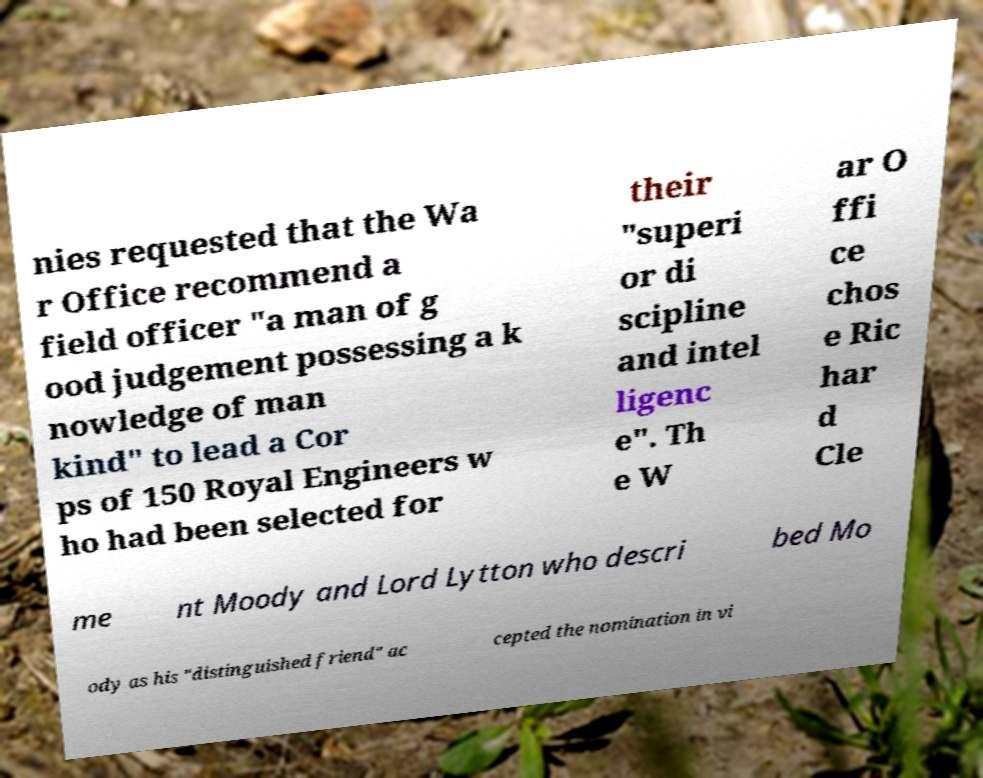Please read and relay the text visible in this image. What does it say? nies requested that the Wa r Office recommend a field officer "a man of g ood judgement possessing a k nowledge of man kind" to lead a Cor ps of 150 Royal Engineers w ho had been selected for their "superi or di scipline and intel ligenc e". Th e W ar O ffi ce chos e Ric har d Cle me nt Moody and Lord Lytton who descri bed Mo ody as his "distinguished friend" ac cepted the nomination in vi 